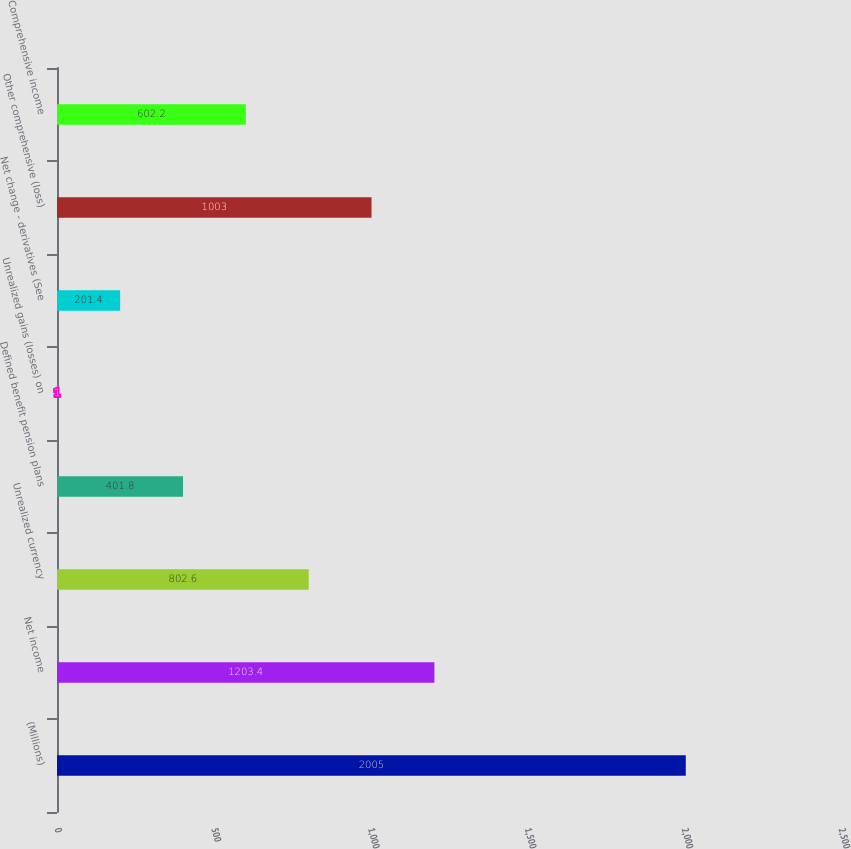Convert chart to OTSL. <chart><loc_0><loc_0><loc_500><loc_500><bar_chart><fcel>(Millions)<fcel>Net income<fcel>Unrealized currency<fcel>Defined benefit pension plans<fcel>Unrealized gains (losses) on<fcel>Net change - derivatives (See<fcel>Other comprehensive (loss)<fcel>Comprehensive income<nl><fcel>2005<fcel>1203.4<fcel>802.6<fcel>401.8<fcel>1<fcel>201.4<fcel>1003<fcel>602.2<nl></chart> 